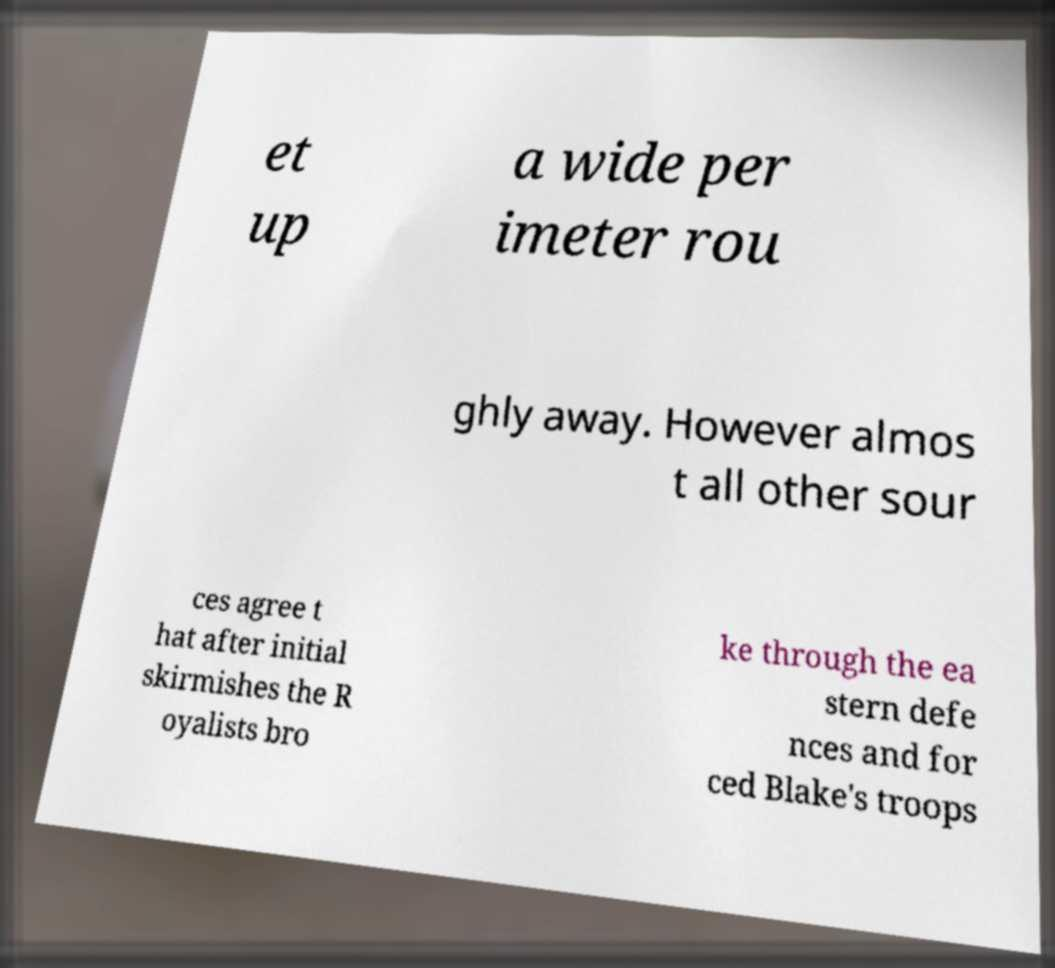I need the written content from this picture converted into text. Can you do that? et up a wide per imeter rou ghly away. However almos t all other sour ces agree t hat after initial skirmishes the R oyalists bro ke through the ea stern defe nces and for ced Blake's troops 